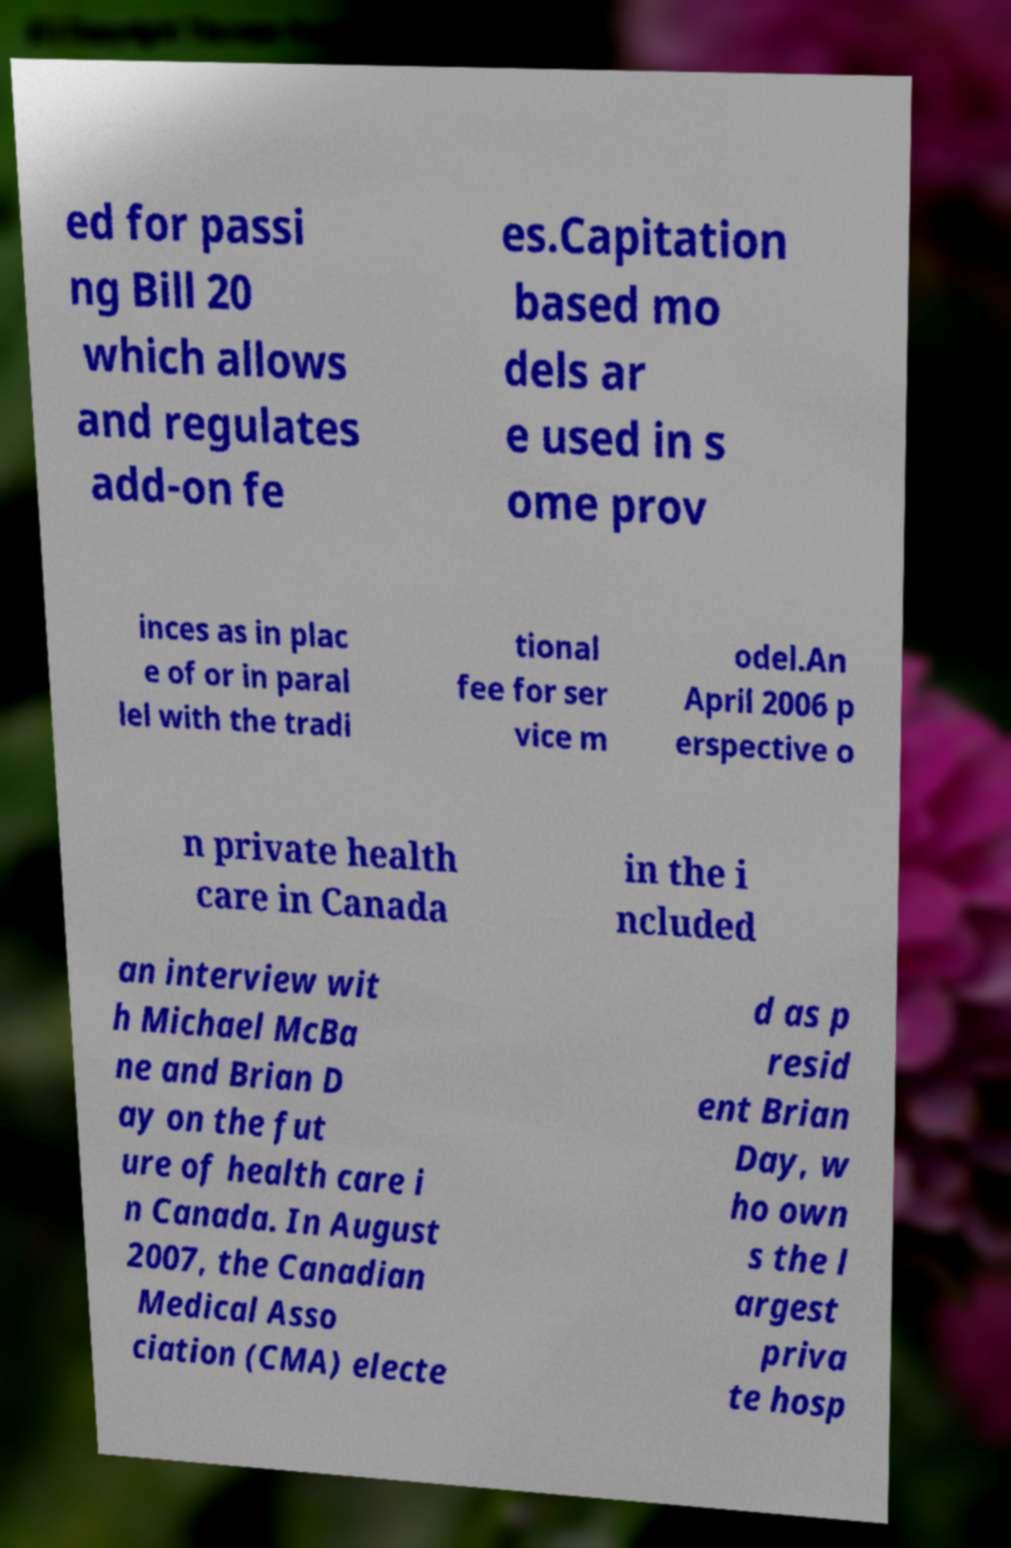Please identify and transcribe the text found in this image. ed for passi ng Bill 20 which allows and regulates add-on fe es.Capitation based mo dels ar e used in s ome prov inces as in plac e of or in paral lel with the tradi tional fee for ser vice m odel.An April 2006 p erspective o n private health care in Canada in the i ncluded an interview wit h Michael McBa ne and Brian D ay on the fut ure of health care i n Canada. In August 2007, the Canadian Medical Asso ciation (CMA) electe d as p resid ent Brian Day, w ho own s the l argest priva te hosp 